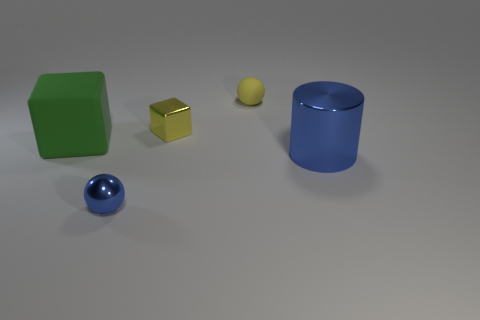Does the tiny yellow thing that is in front of the yellow rubber object have the same material as the big thing that is to the left of the tiny metal block? No, the tiny yellow object in front of the yellow rubber object appears to be a small sphere, likely a small ball or pellet, which does not have the same material as the large blue thing to the left of the tiny metal block, which appears to be a cylinder made of a shiny, plastic-like material. 